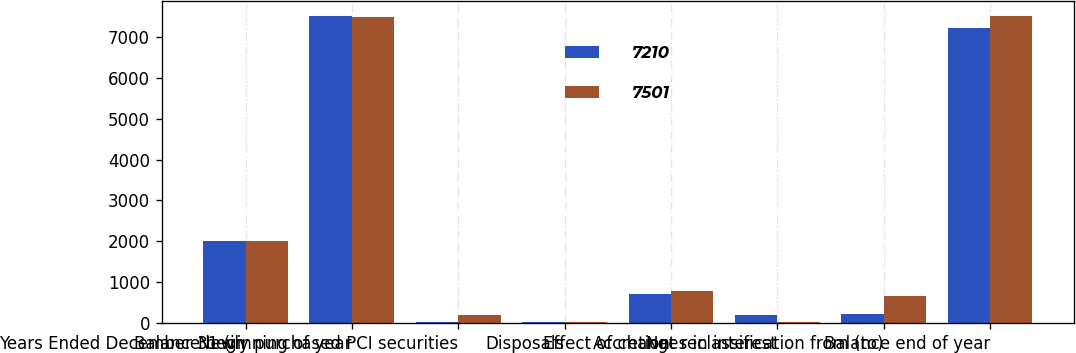Convert chart to OTSL. <chart><loc_0><loc_0><loc_500><loc_500><stacked_bar_chart><ecel><fcel>Years Ended December 31 (in<fcel>Balance beginning of year<fcel>Newly purchased PCI securities<fcel>Disposals<fcel>Accretion<fcel>Effect of changes in interest<fcel>Net reclassification from (to)<fcel>Balance end of year<nl><fcel>7210<fcel>2018<fcel>7501<fcel>33<fcel>21<fcel>722<fcel>207<fcel>212<fcel>7210<nl><fcel>7501<fcel>2017<fcel>7498<fcel>190<fcel>18<fcel>797<fcel>34<fcel>662<fcel>7501<nl></chart> 